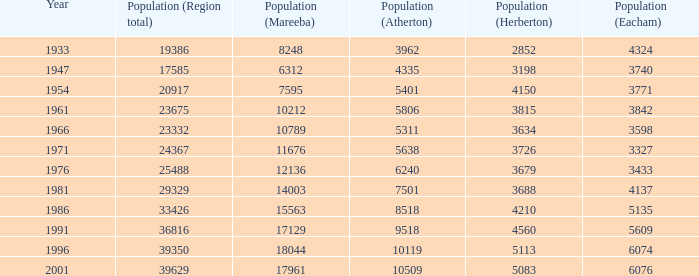What was the smallest population figure for Mareeba? 6312.0. 